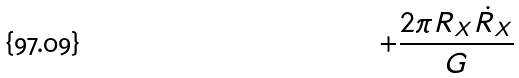<formula> <loc_0><loc_0><loc_500><loc_500>+ \frac { 2 \pi R _ { X } \dot { R } _ { X } } { G }</formula> 